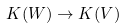<formula> <loc_0><loc_0><loc_500><loc_500>K ( W ) \to K ( V )</formula> 